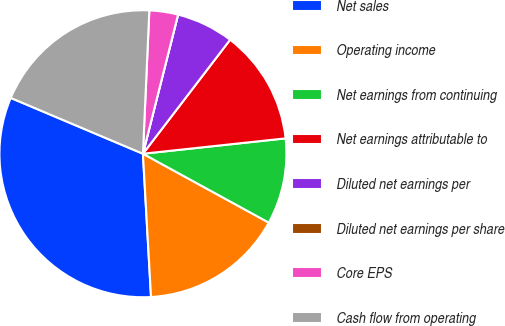<chart> <loc_0><loc_0><loc_500><loc_500><pie_chart><fcel>Net sales<fcel>Operating income<fcel>Net earnings from continuing<fcel>Net earnings attributable to<fcel>Diluted net earnings per<fcel>Diluted net earnings per share<fcel>Core EPS<fcel>Cash flow from operating<nl><fcel>32.26%<fcel>16.13%<fcel>9.68%<fcel>12.9%<fcel>6.45%<fcel>0.0%<fcel>3.23%<fcel>19.35%<nl></chart> 